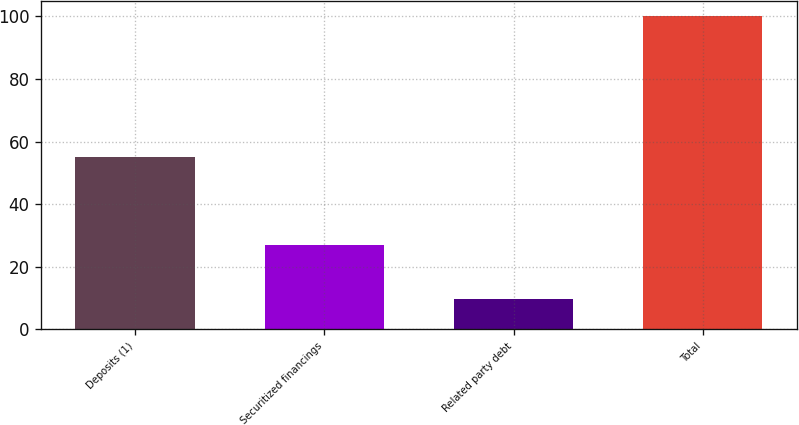Convert chart to OTSL. <chart><loc_0><loc_0><loc_500><loc_500><bar_chart><fcel>Deposits (1)<fcel>Securitized financings<fcel>Related party debt<fcel>Total<nl><fcel>55<fcel>27.1<fcel>9.8<fcel>100<nl></chart> 